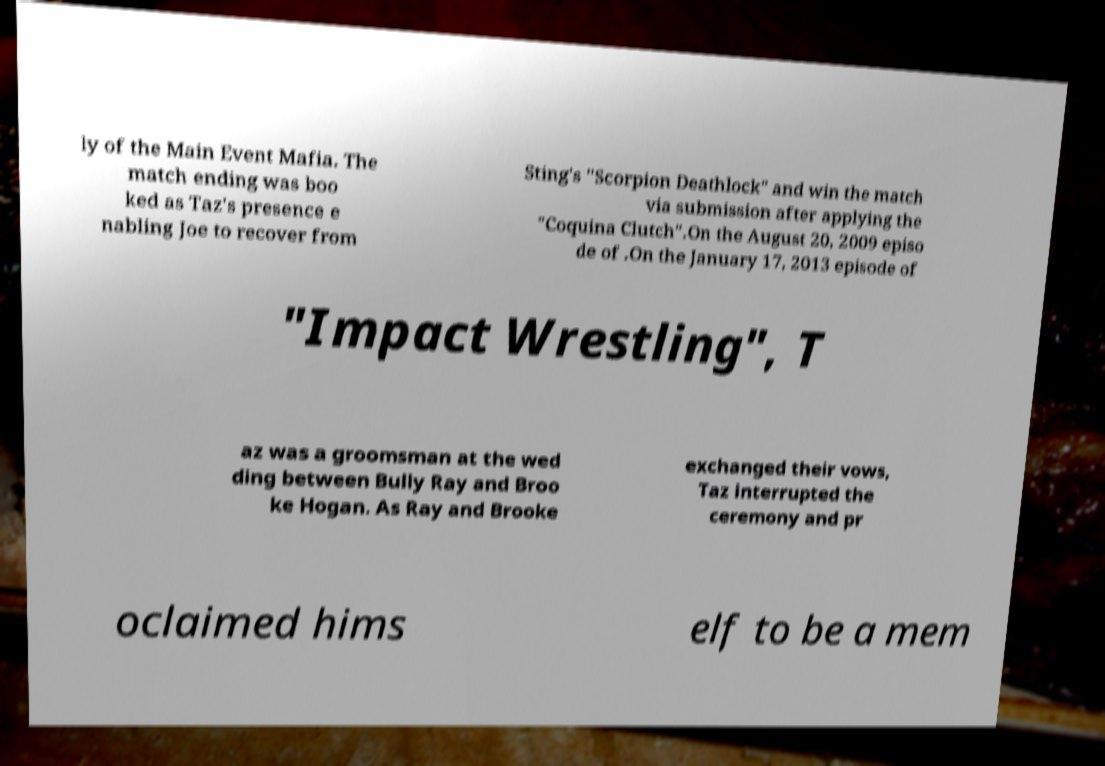What messages or text are displayed in this image? I need them in a readable, typed format. ly of the Main Event Mafia. The match ending was boo ked as Taz's presence e nabling Joe to recover from Sting's "Scorpion Deathlock" and win the match via submission after applying the "Coquina Clutch".On the August 20, 2009 episo de of .On the January 17, 2013 episode of "Impact Wrestling", T az was a groomsman at the wed ding between Bully Ray and Broo ke Hogan. As Ray and Brooke exchanged their vows, Taz interrupted the ceremony and pr oclaimed hims elf to be a mem 